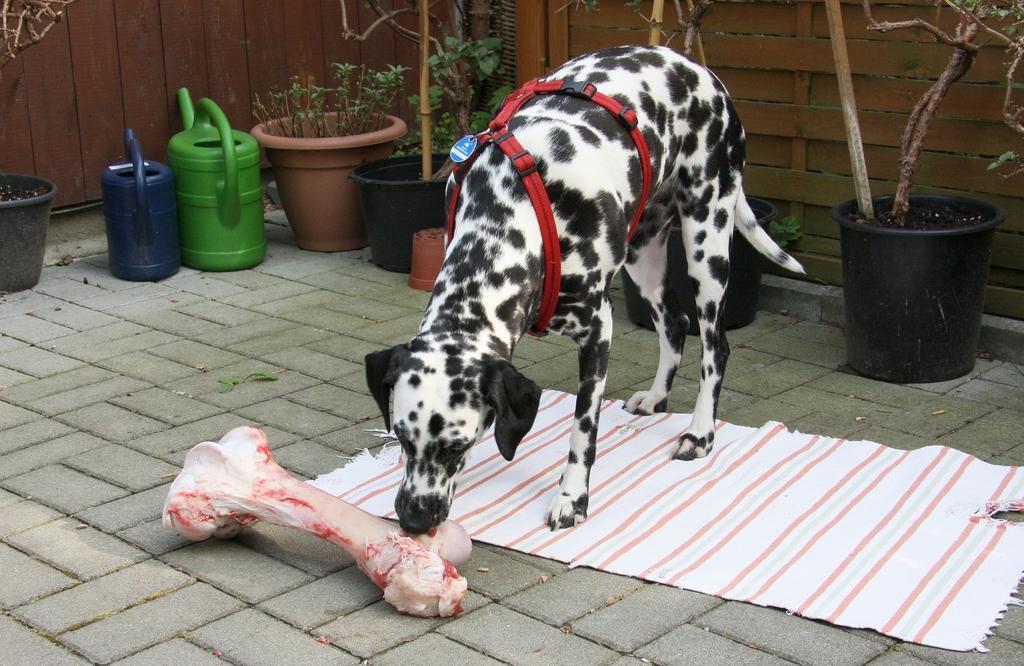Could you give a brief overview of what you see in this image? In this picture we can see a dog, meat, cloth, house plants and water cans on the floor. In the background we can see sticks and the walls. 